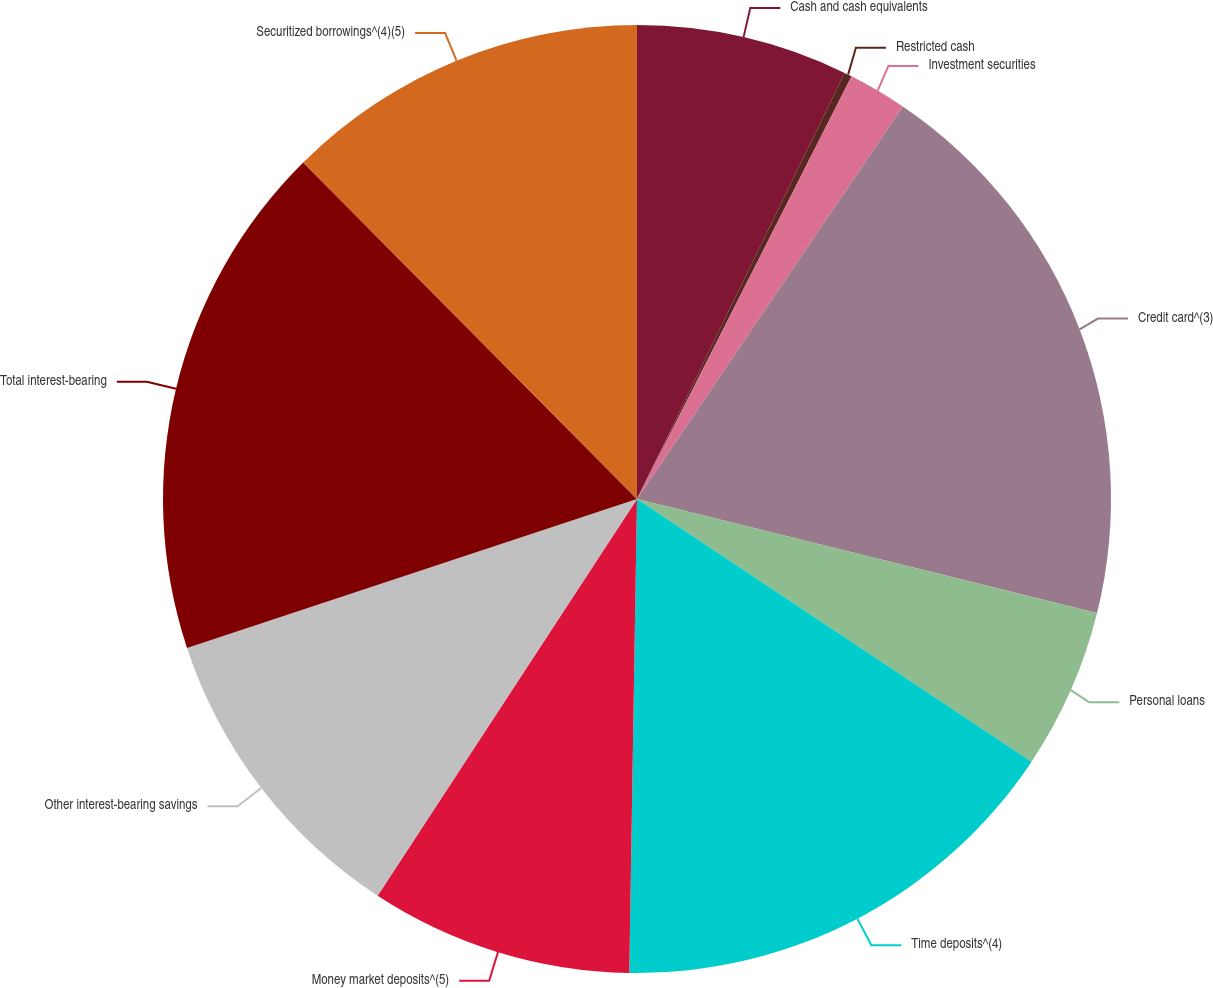Convert chart to OTSL. <chart><loc_0><loc_0><loc_500><loc_500><pie_chart><fcel>Cash and cash equivalents<fcel>Restricted cash<fcel>Investment securities<fcel>Credit card^(3)<fcel>Personal loans<fcel>Time deposits^(4)<fcel>Money market deposits^(5)<fcel>Other interest-bearing savings<fcel>Total interest-bearing<fcel>Securitized borrowings^(4)(5)<nl><fcel>7.22%<fcel>0.26%<fcel>2.0%<fcel>19.4%<fcel>5.48%<fcel>15.92%<fcel>8.96%<fcel>10.7%<fcel>17.66%<fcel>12.44%<nl></chart> 